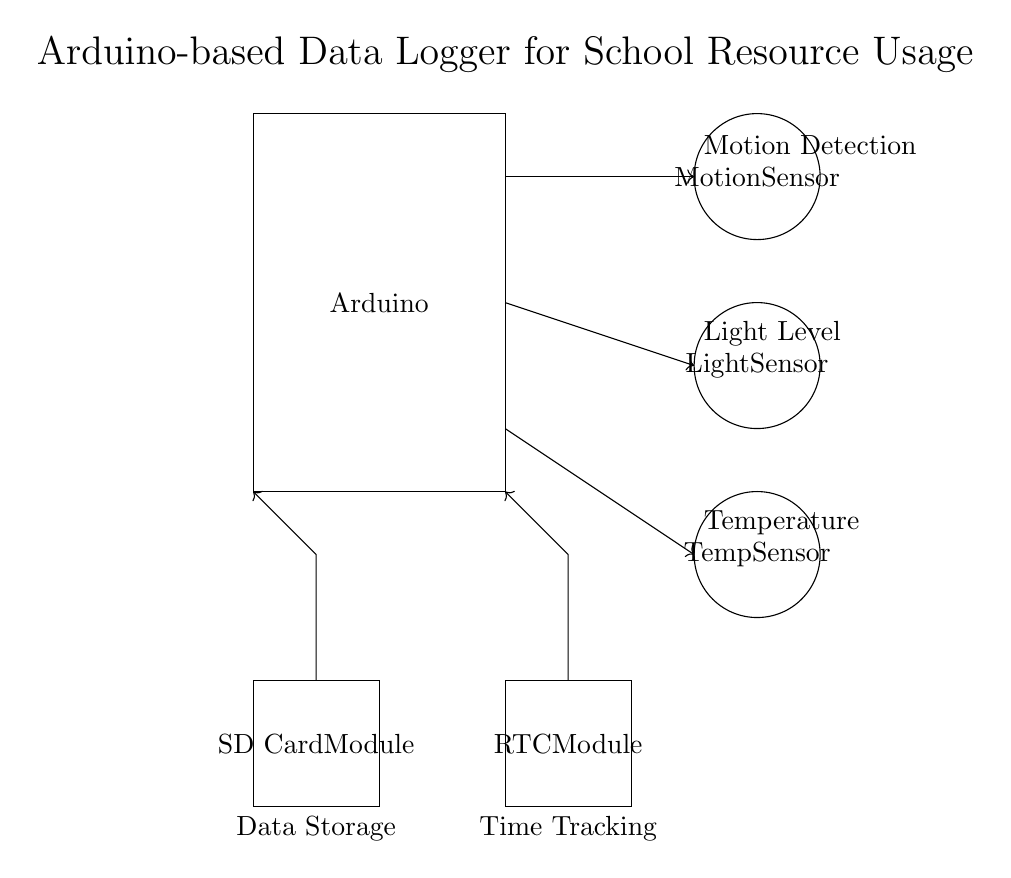What components are used in this data logger? The components visible in the circuit diagram are an Arduino, a motion sensor, a light sensor, a temperature sensor, an SD card module, and a real-time clock (RTC) module.
Answer: Arduino, motion sensor, light sensor, temperature sensor, SD card module, RTC module What is the purpose of the SD card module? The SD card module is used for data storage. It allows the Arduino to save the sensor readings for later retrieval and analysis.
Answer: Data storage Which sensor detects light levels? The light sensor, as indicated in the circuit diagram, is specifically designated to measure light levels for the data logger.
Answer: Light sensor What kind of module is used for time tracking? The real-time clock (RTC) module is used to track and record the time associated with the data collected by the sensors.
Answer: RTC module How are the sensors connected to the Arduino? Each sensor is connected through directed lines indicating their connections, with arrows leading from the Arduino to each sensor, suggesting data flow from the Arduino to the sensors.
Answer: Through directed lines with arrows What does the motion sensor do? The motion sensor detects motion in the vicinity and signals the Arduino, which can log this information into the SD card alongside other data.
Answer: Detects motion How does the Arduino process the collected data? The Arduino receives input signals from the sensors, processes the data, and then records it on the SD card with timestamps from the RTC module.
Answer: Receives, processes, records 